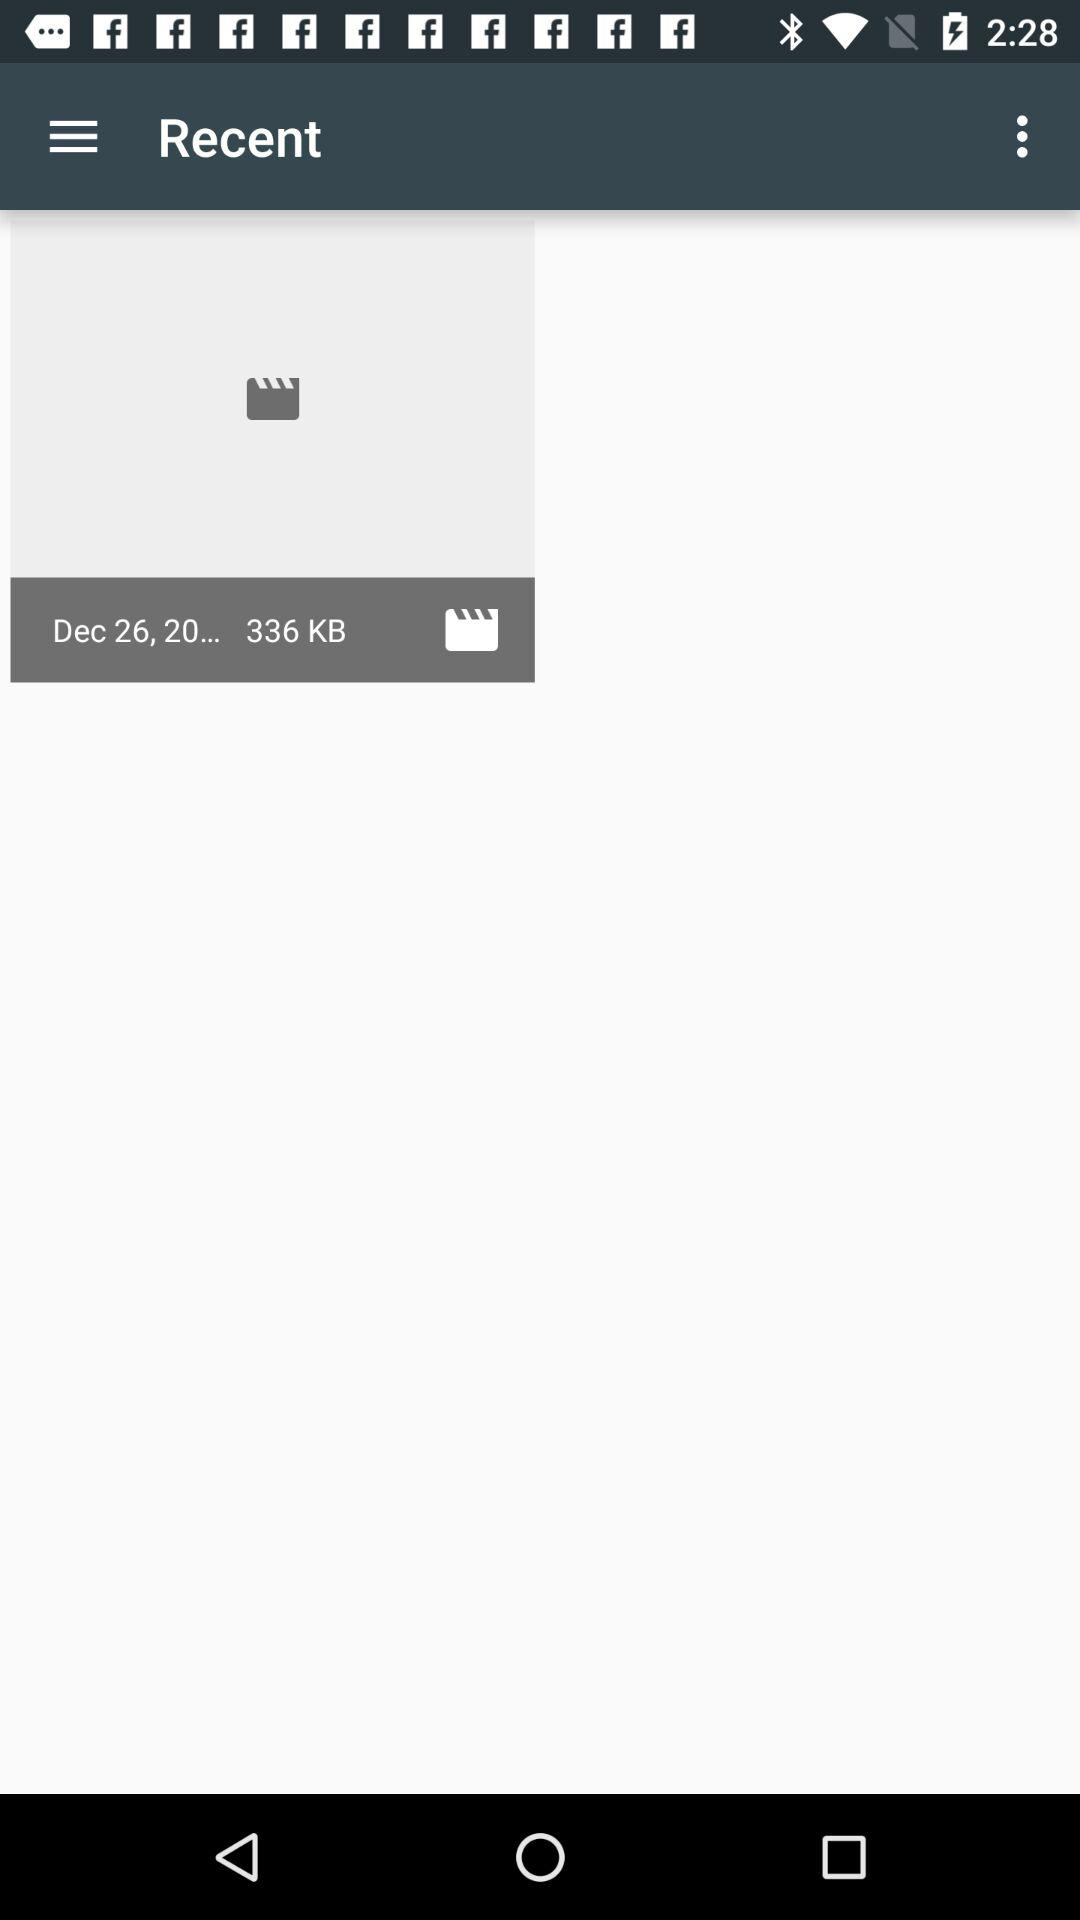What is the size of the file in "Recent"? The size of the file in "Recent" is 336 KB. 